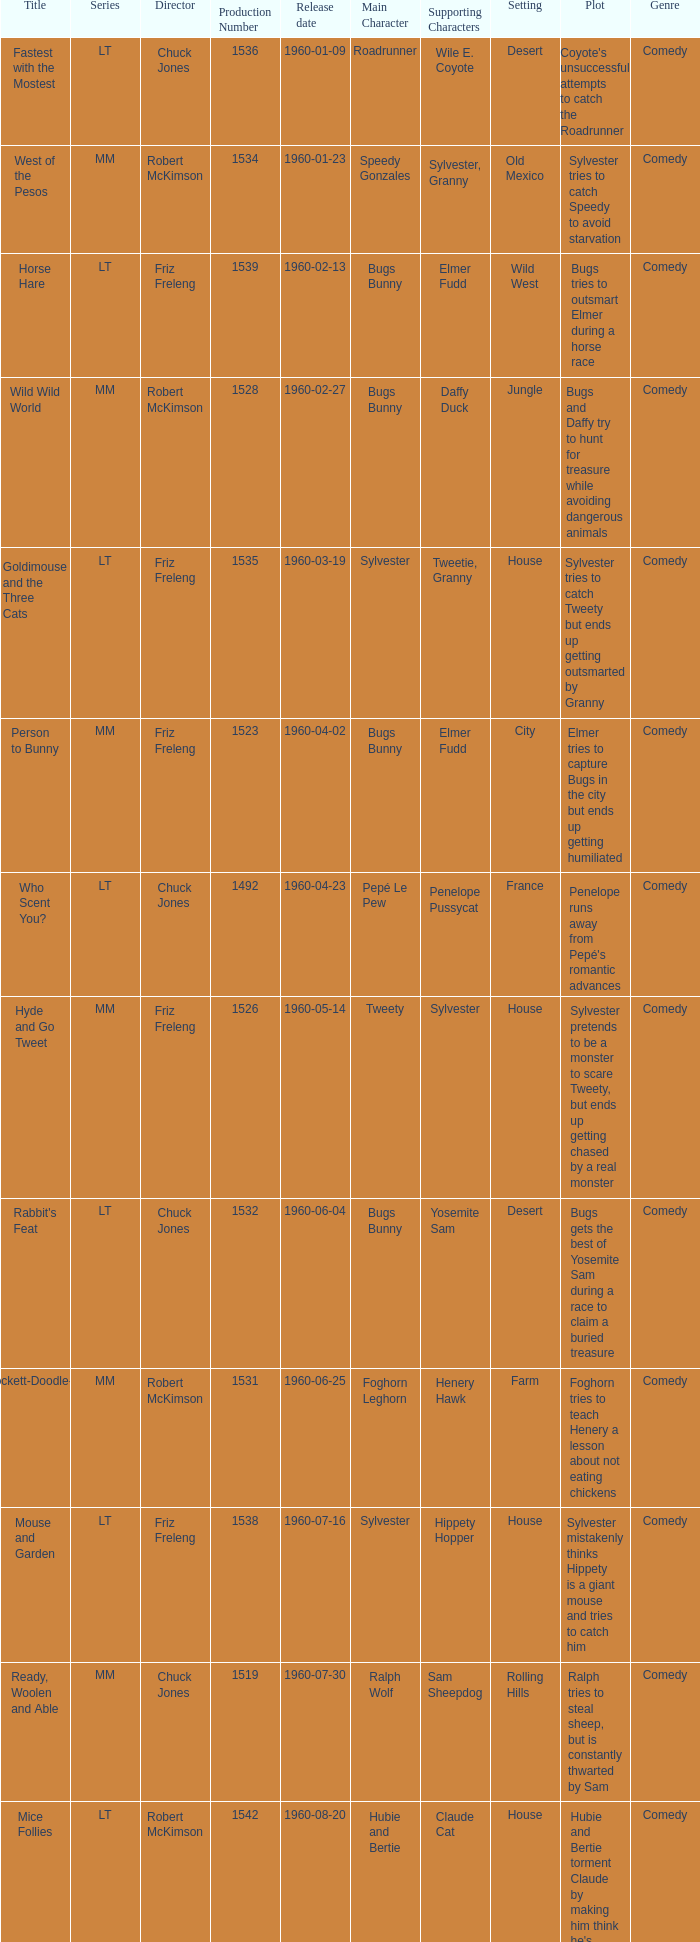What is the production number for the episode directed by Robert McKimson named Mice Follies? 1.0. 